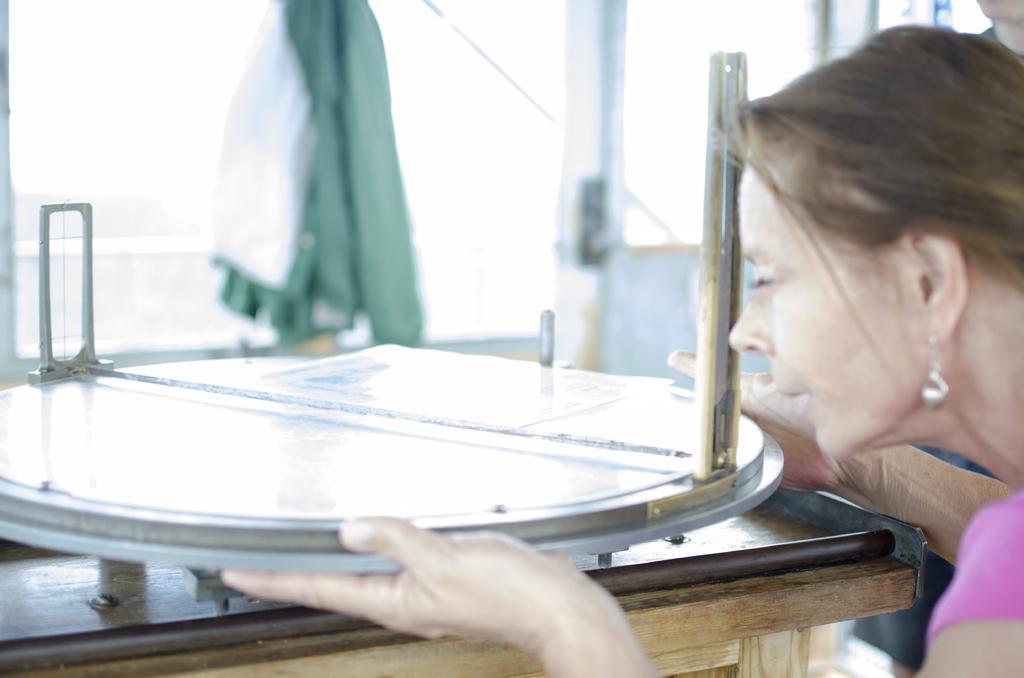Can you describe this image briefly? On the right side of the image we can see one person holding some object. In front of her, we can see one table. On the table, we can see a few other objects. In the background there is a wall, cloth, glass and a few other objects. 